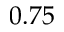<formula> <loc_0><loc_0><loc_500><loc_500>0 . 7 5</formula> 